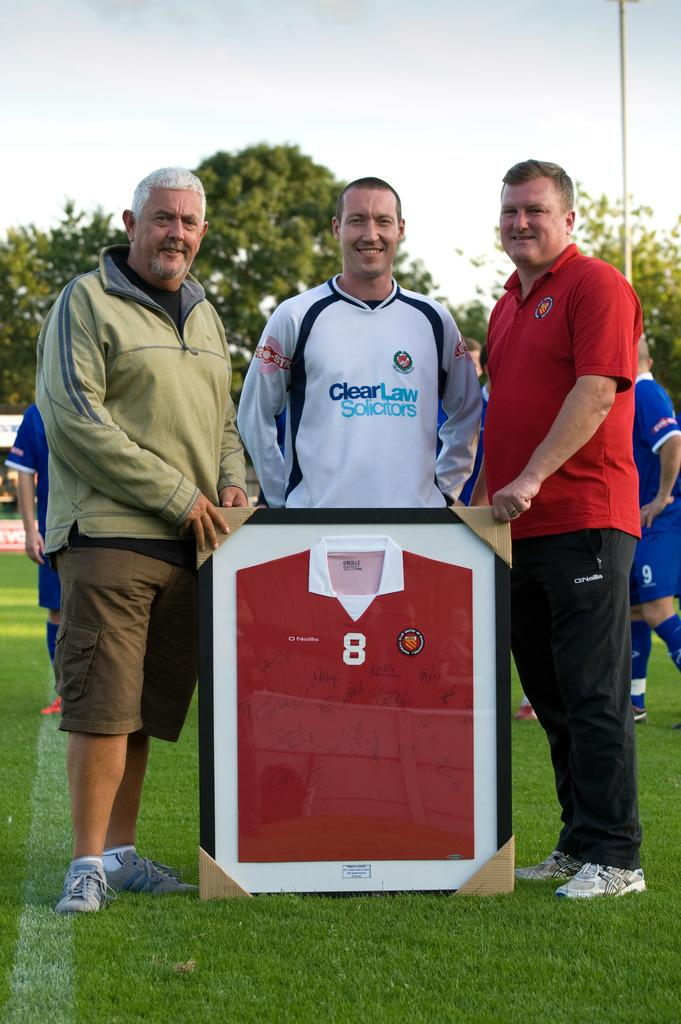<image>
Offer a succinct explanation of the picture presented. Three men, the middle one wearing a white top with CLear Law Solicitiors on it, pose with a framed red football top which bears many autographs and the number 8 